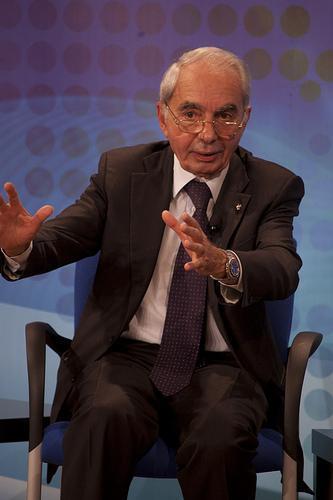How many hands is the old man raising up?
Give a very brief answer. 2. 